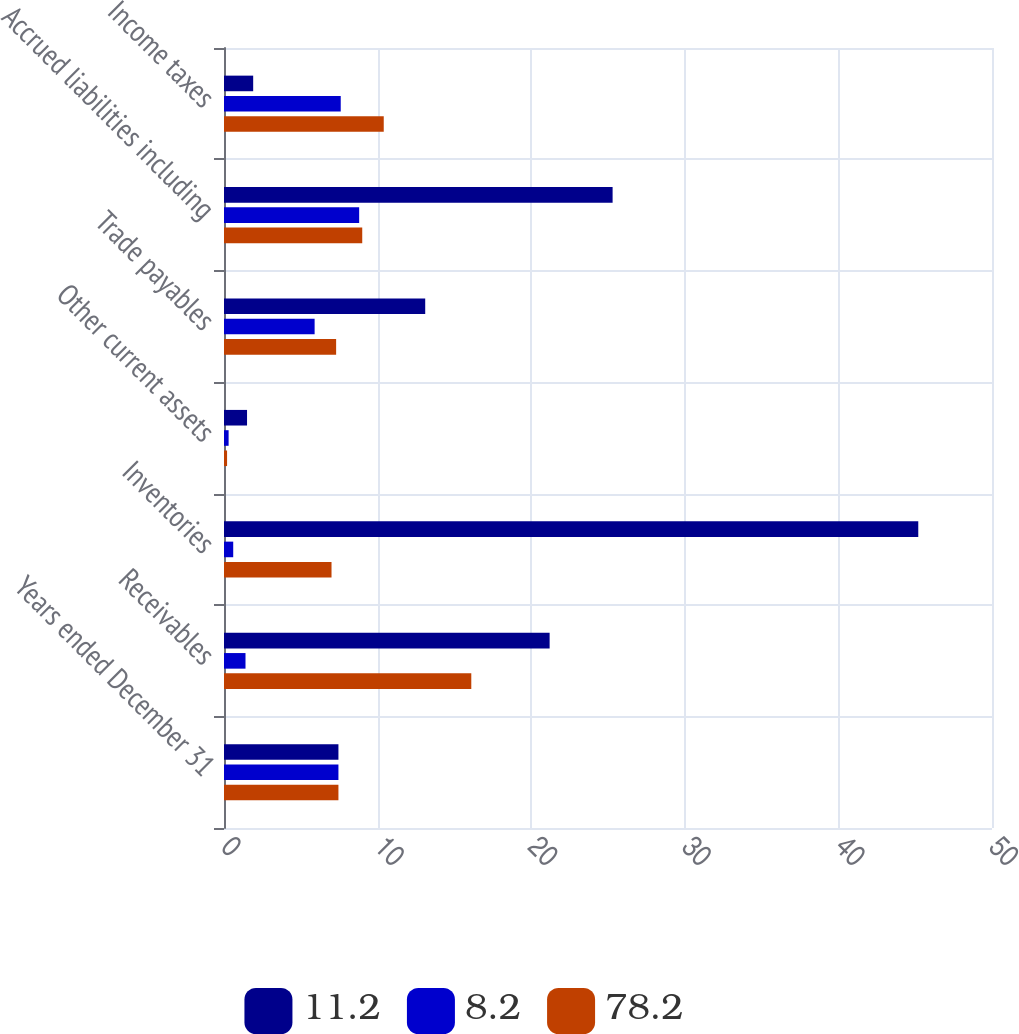Convert chart to OTSL. <chart><loc_0><loc_0><loc_500><loc_500><stacked_bar_chart><ecel><fcel>Years ended December 31<fcel>Receivables<fcel>Inventories<fcel>Other current assets<fcel>Trade payables<fcel>Accrued liabilities including<fcel>Income taxes<nl><fcel>11.2<fcel>7.45<fcel>21.2<fcel>45.2<fcel>1.5<fcel>13.1<fcel>25.3<fcel>1.9<nl><fcel>8.2<fcel>7.45<fcel>1.4<fcel>0.6<fcel>0.3<fcel>5.9<fcel>8.8<fcel>7.6<nl><fcel>78.2<fcel>7.45<fcel>16.1<fcel>7<fcel>0.2<fcel>7.3<fcel>9<fcel>10.4<nl></chart> 